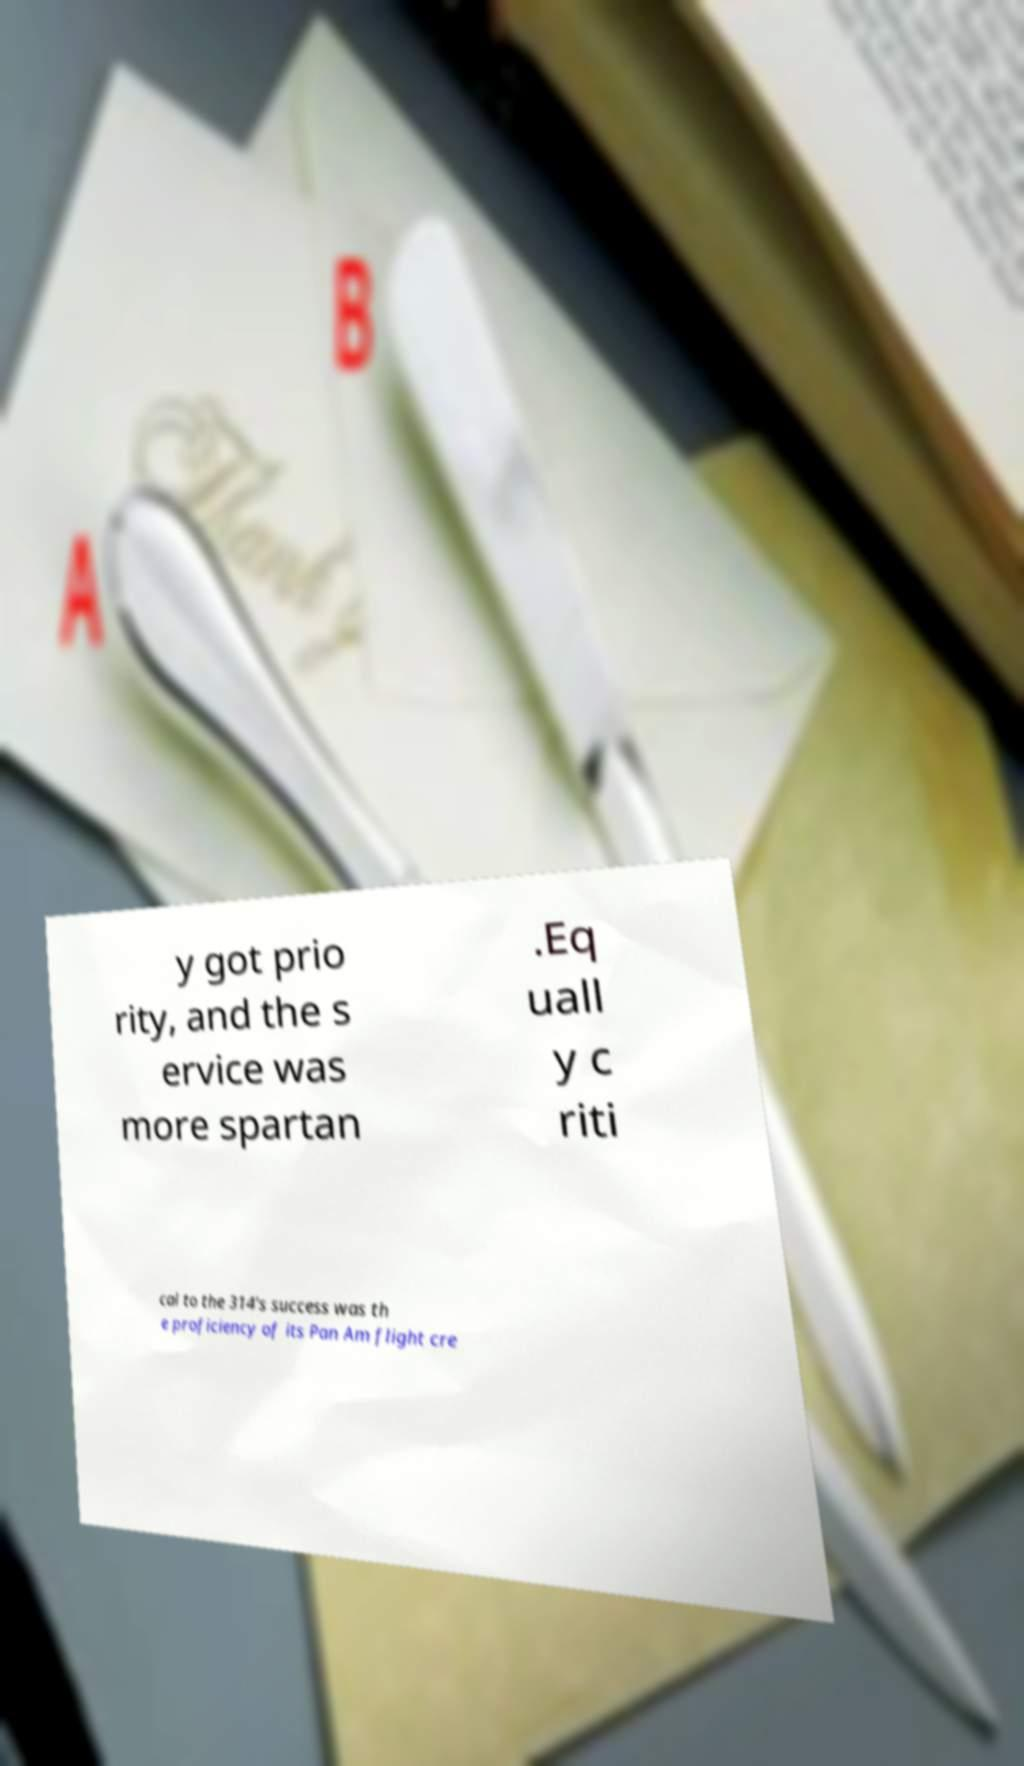Could you assist in decoding the text presented in this image and type it out clearly? y got prio rity, and the s ervice was more spartan .Eq uall y c riti cal to the 314's success was th e proficiency of its Pan Am flight cre 